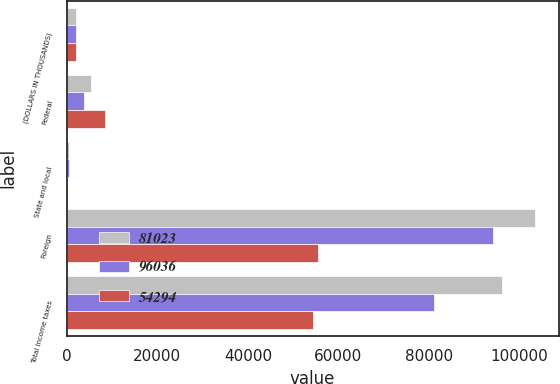Convert chart to OTSL. <chart><loc_0><loc_0><loc_500><loc_500><stacked_bar_chart><ecel><fcel>(DOLLARS IN THOUSANDS)<fcel>Federal<fcel>State and local<fcel>Foreign<fcel>Total income taxes<nl><fcel>81023<fcel>2010<fcel>5379<fcel>507<fcel>103451<fcel>96036<nl><fcel>96036<fcel>2009<fcel>3829<fcel>413<fcel>94135<fcel>81023<nl><fcel>54294<fcel>2008<fcel>8363<fcel>94<fcel>55490<fcel>54294<nl></chart> 